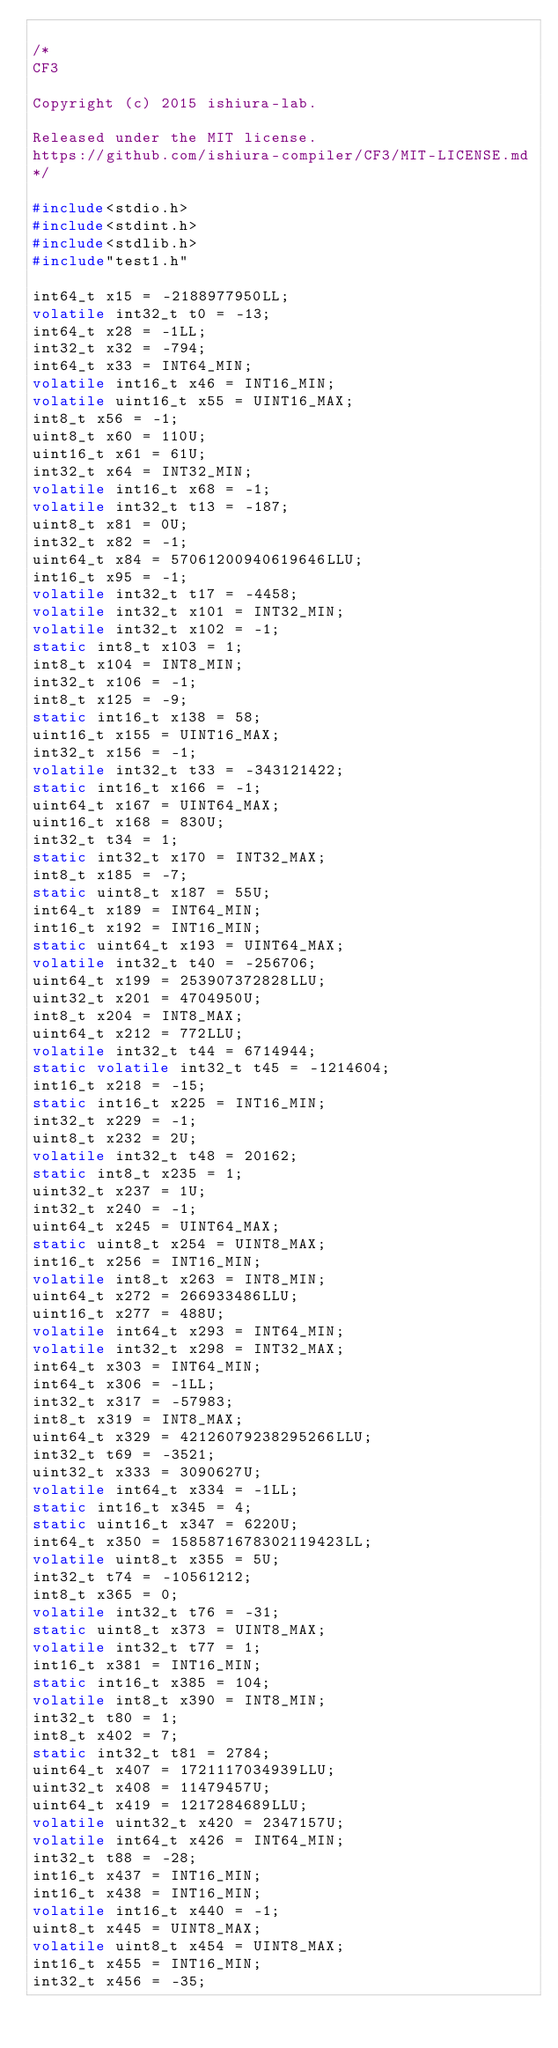Convert code to text. <code><loc_0><loc_0><loc_500><loc_500><_C_>
/*
CF3

Copyright (c) 2015 ishiura-lab.

Released under the MIT license.  
https://github.com/ishiura-compiler/CF3/MIT-LICENSE.md
*/

#include<stdio.h>
#include<stdint.h>
#include<stdlib.h>
#include"test1.h"

int64_t x15 = -2188977950LL;
volatile int32_t t0 = -13;
int64_t x28 = -1LL;
int32_t x32 = -794;
int64_t x33 = INT64_MIN;
volatile int16_t x46 = INT16_MIN;
volatile uint16_t x55 = UINT16_MAX;
int8_t x56 = -1;
uint8_t x60 = 110U;
uint16_t x61 = 61U;
int32_t x64 = INT32_MIN;
volatile int16_t x68 = -1;
volatile int32_t t13 = -187;
uint8_t x81 = 0U;
int32_t x82 = -1;
uint64_t x84 = 57061200940619646LLU;
int16_t x95 = -1;
volatile int32_t t17 = -4458;
volatile int32_t x101 = INT32_MIN;
volatile int32_t x102 = -1;
static int8_t x103 = 1;
int8_t x104 = INT8_MIN;
int32_t x106 = -1;
int8_t x125 = -9;
static int16_t x138 = 58;
uint16_t x155 = UINT16_MAX;
int32_t x156 = -1;
volatile int32_t t33 = -343121422;
static int16_t x166 = -1;
uint64_t x167 = UINT64_MAX;
uint16_t x168 = 830U;
int32_t t34 = 1;
static int32_t x170 = INT32_MAX;
int8_t x185 = -7;
static uint8_t x187 = 55U;
int64_t x189 = INT64_MIN;
int16_t x192 = INT16_MIN;
static uint64_t x193 = UINT64_MAX;
volatile int32_t t40 = -256706;
uint64_t x199 = 253907372828LLU;
uint32_t x201 = 4704950U;
int8_t x204 = INT8_MAX;
uint64_t x212 = 772LLU;
volatile int32_t t44 = 6714944;
static volatile int32_t t45 = -1214604;
int16_t x218 = -15;
static int16_t x225 = INT16_MIN;
int32_t x229 = -1;
uint8_t x232 = 2U;
volatile int32_t t48 = 20162;
static int8_t x235 = 1;
uint32_t x237 = 1U;
int32_t x240 = -1;
uint64_t x245 = UINT64_MAX;
static uint8_t x254 = UINT8_MAX;
int16_t x256 = INT16_MIN;
volatile int8_t x263 = INT8_MIN;
uint64_t x272 = 266933486LLU;
uint16_t x277 = 488U;
volatile int64_t x293 = INT64_MIN;
volatile int32_t x298 = INT32_MAX;
int64_t x303 = INT64_MIN;
int64_t x306 = -1LL;
int32_t x317 = -57983;
int8_t x319 = INT8_MAX;
uint64_t x329 = 42126079238295266LLU;
int32_t t69 = -3521;
uint32_t x333 = 3090627U;
volatile int64_t x334 = -1LL;
static int16_t x345 = 4;
static uint16_t x347 = 6220U;
int64_t x350 = 1585871678302119423LL;
volatile uint8_t x355 = 5U;
int32_t t74 = -10561212;
int8_t x365 = 0;
volatile int32_t t76 = -31;
static uint8_t x373 = UINT8_MAX;
volatile int32_t t77 = 1;
int16_t x381 = INT16_MIN;
static int16_t x385 = 104;
volatile int8_t x390 = INT8_MIN;
int32_t t80 = 1;
int8_t x402 = 7;
static int32_t t81 = 2784;
uint64_t x407 = 1721117034939LLU;
uint32_t x408 = 11479457U;
uint64_t x419 = 1217284689LLU;
volatile uint32_t x420 = 2347157U;
volatile int64_t x426 = INT64_MIN;
int32_t t88 = -28;
int16_t x437 = INT16_MIN;
int16_t x438 = INT16_MIN;
volatile int16_t x440 = -1;
uint8_t x445 = UINT8_MAX;
volatile uint8_t x454 = UINT8_MAX;
int16_t x455 = INT16_MIN;
int32_t x456 = -35;</code> 